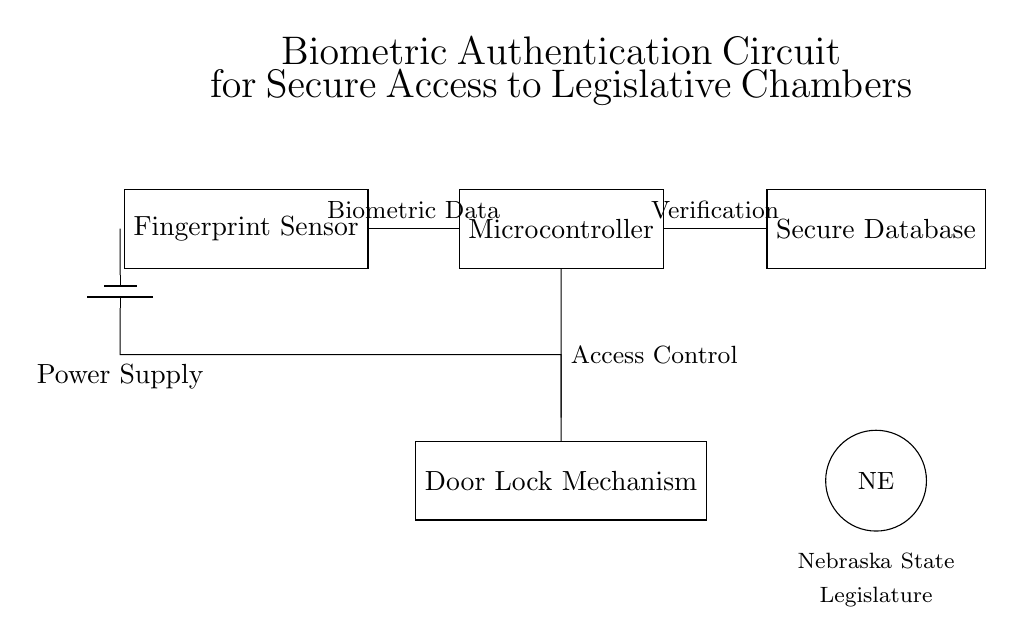What component collects biometric data? The Fingerprint Sensor is the component designated for collecting biometric data from users trying to gain access.
Answer: Fingerprint Sensor Which microcontroller does the circuit utilize? Although the specific make and model of the microcontroller are not stated in the diagram, it represents processing and control of the biometric data.
Answer: Microcontroller What is the purpose of the secure database? The secure database is used for storing and verifying the biometric data against stored records to determine access legitimacy.
Answer: Verification How is power supplied to the circuit? The power supply is indicated as a battery connected to the circuit, providing necessary energy for operation.
Answer: Battery What is the function of the door lock mechanism in this circuit? The door lock mechanism is controlled based on the results from the microcontroller following biometric verification, allowing or denying access.
Answer: Access Control How many components are connected directly to the microcontroller? There are three components connected to the microcontroller: the fingerprint sensor, the secure database, and the door lock mechanism.
Answer: Three Which visual element represents the Nebraska State Legislature? The simplified representation of the Nebraska State Seal is depicted as a circle with the letters "NE".
Answer: NE 